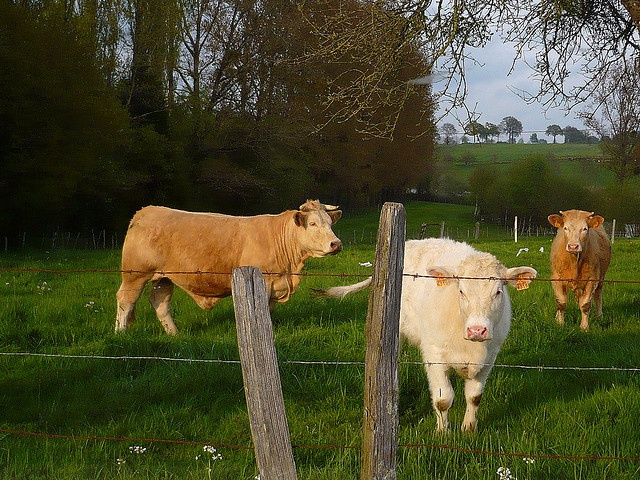Describe the objects in this image and their specific colors. I can see cow in black, olive, tan, and maroon tones, cow in black, tan, and beige tones, and cow in black, brown, maroon, olive, and tan tones in this image. 